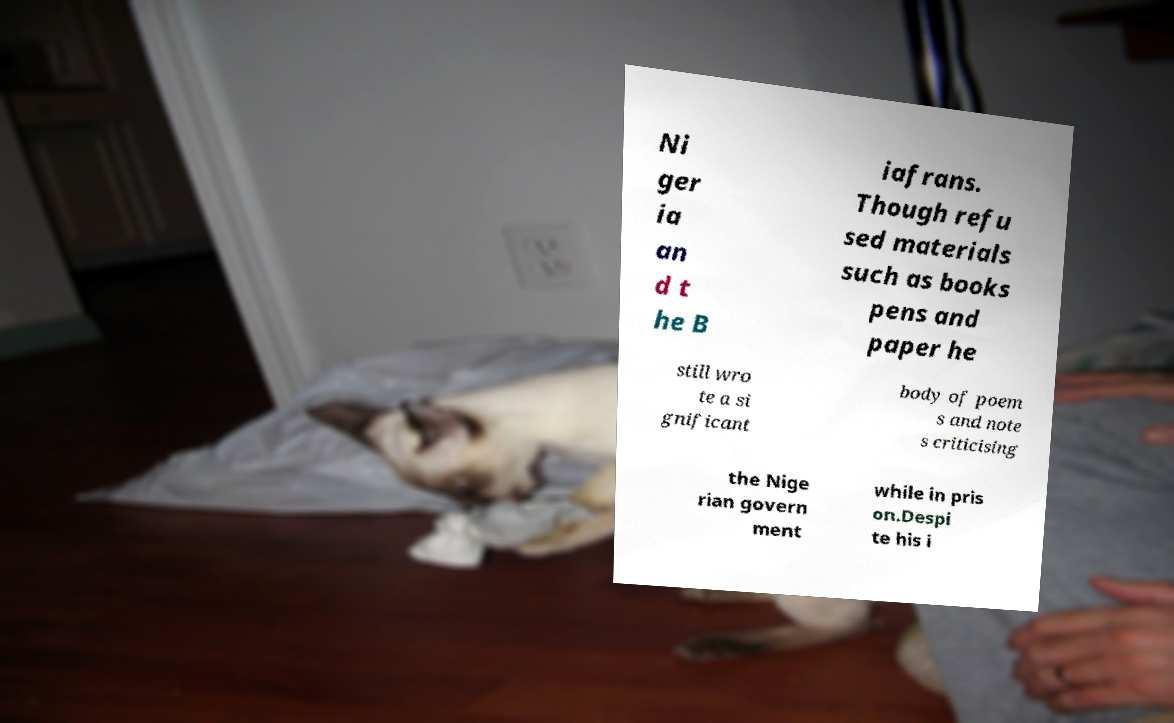For documentation purposes, I need the text within this image transcribed. Could you provide that? Ni ger ia an d t he B iafrans. Though refu sed materials such as books pens and paper he still wro te a si gnificant body of poem s and note s criticising the Nige rian govern ment while in pris on.Despi te his i 